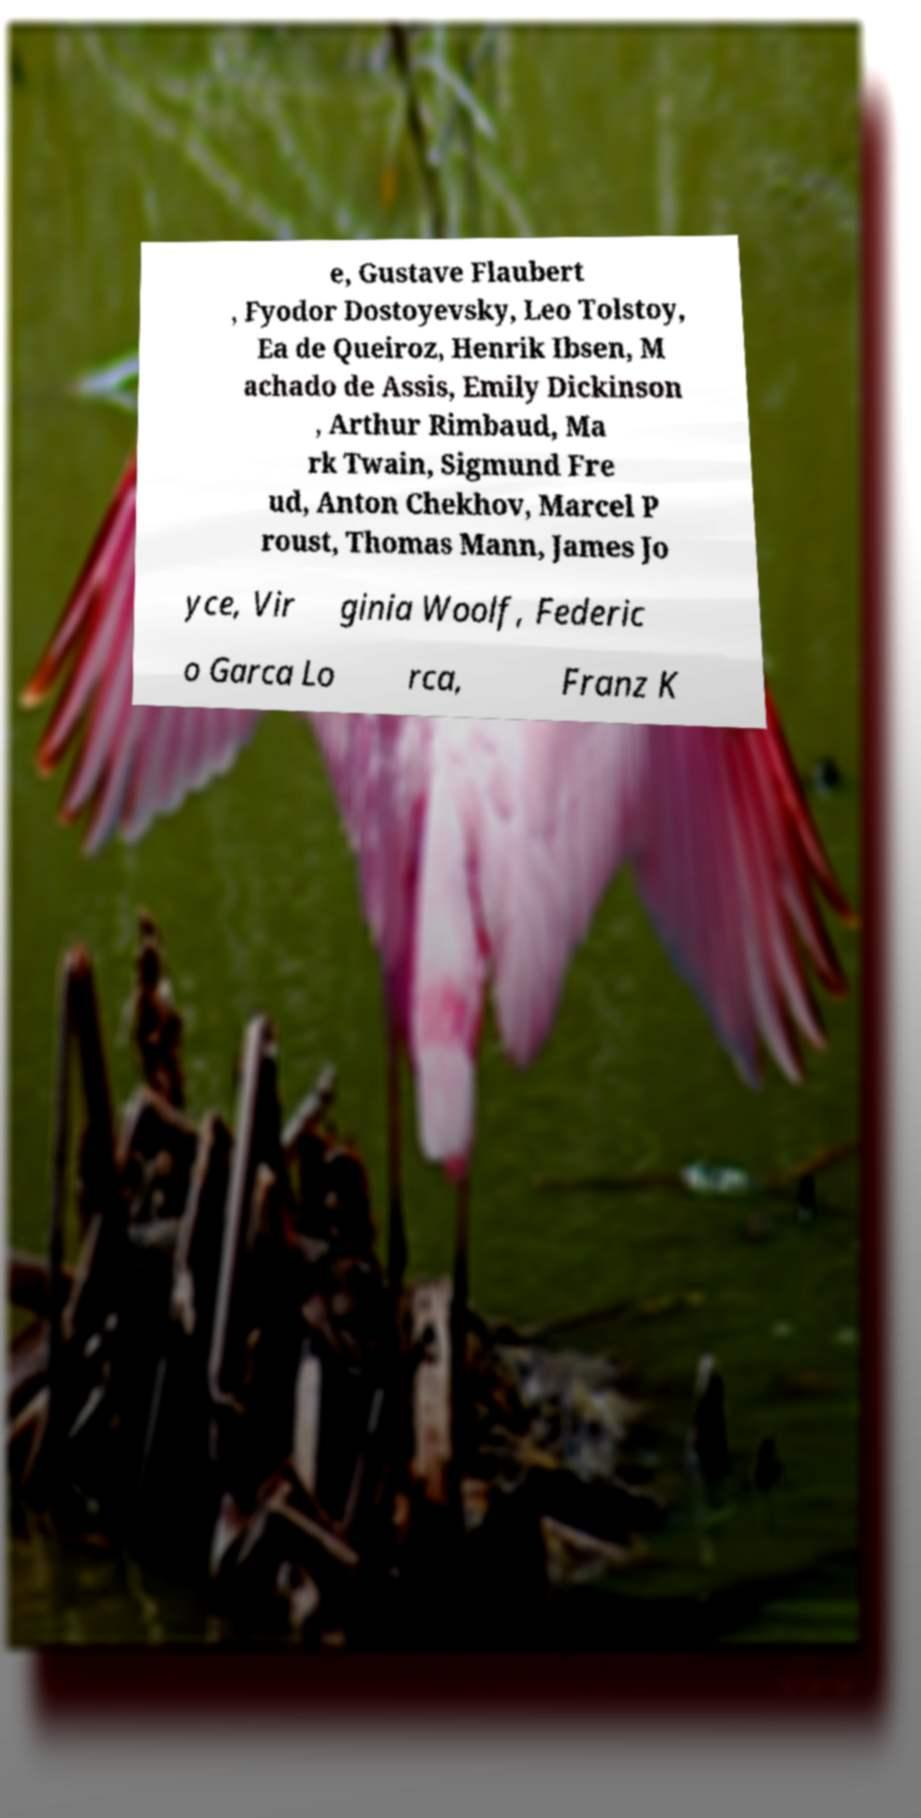What messages or text are displayed in this image? I need them in a readable, typed format. e, Gustave Flaubert , Fyodor Dostoyevsky, Leo Tolstoy, Ea de Queiroz, Henrik Ibsen, M achado de Assis, Emily Dickinson , Arthur Rimbaud, Ma rk Twain, Sigmund Fre ud, Anton Chekhov, Marcel P roust, Thomas Mann, James Jo yce, Vir ginia Woolf, Federic o Garca Lo rca, Franz K 